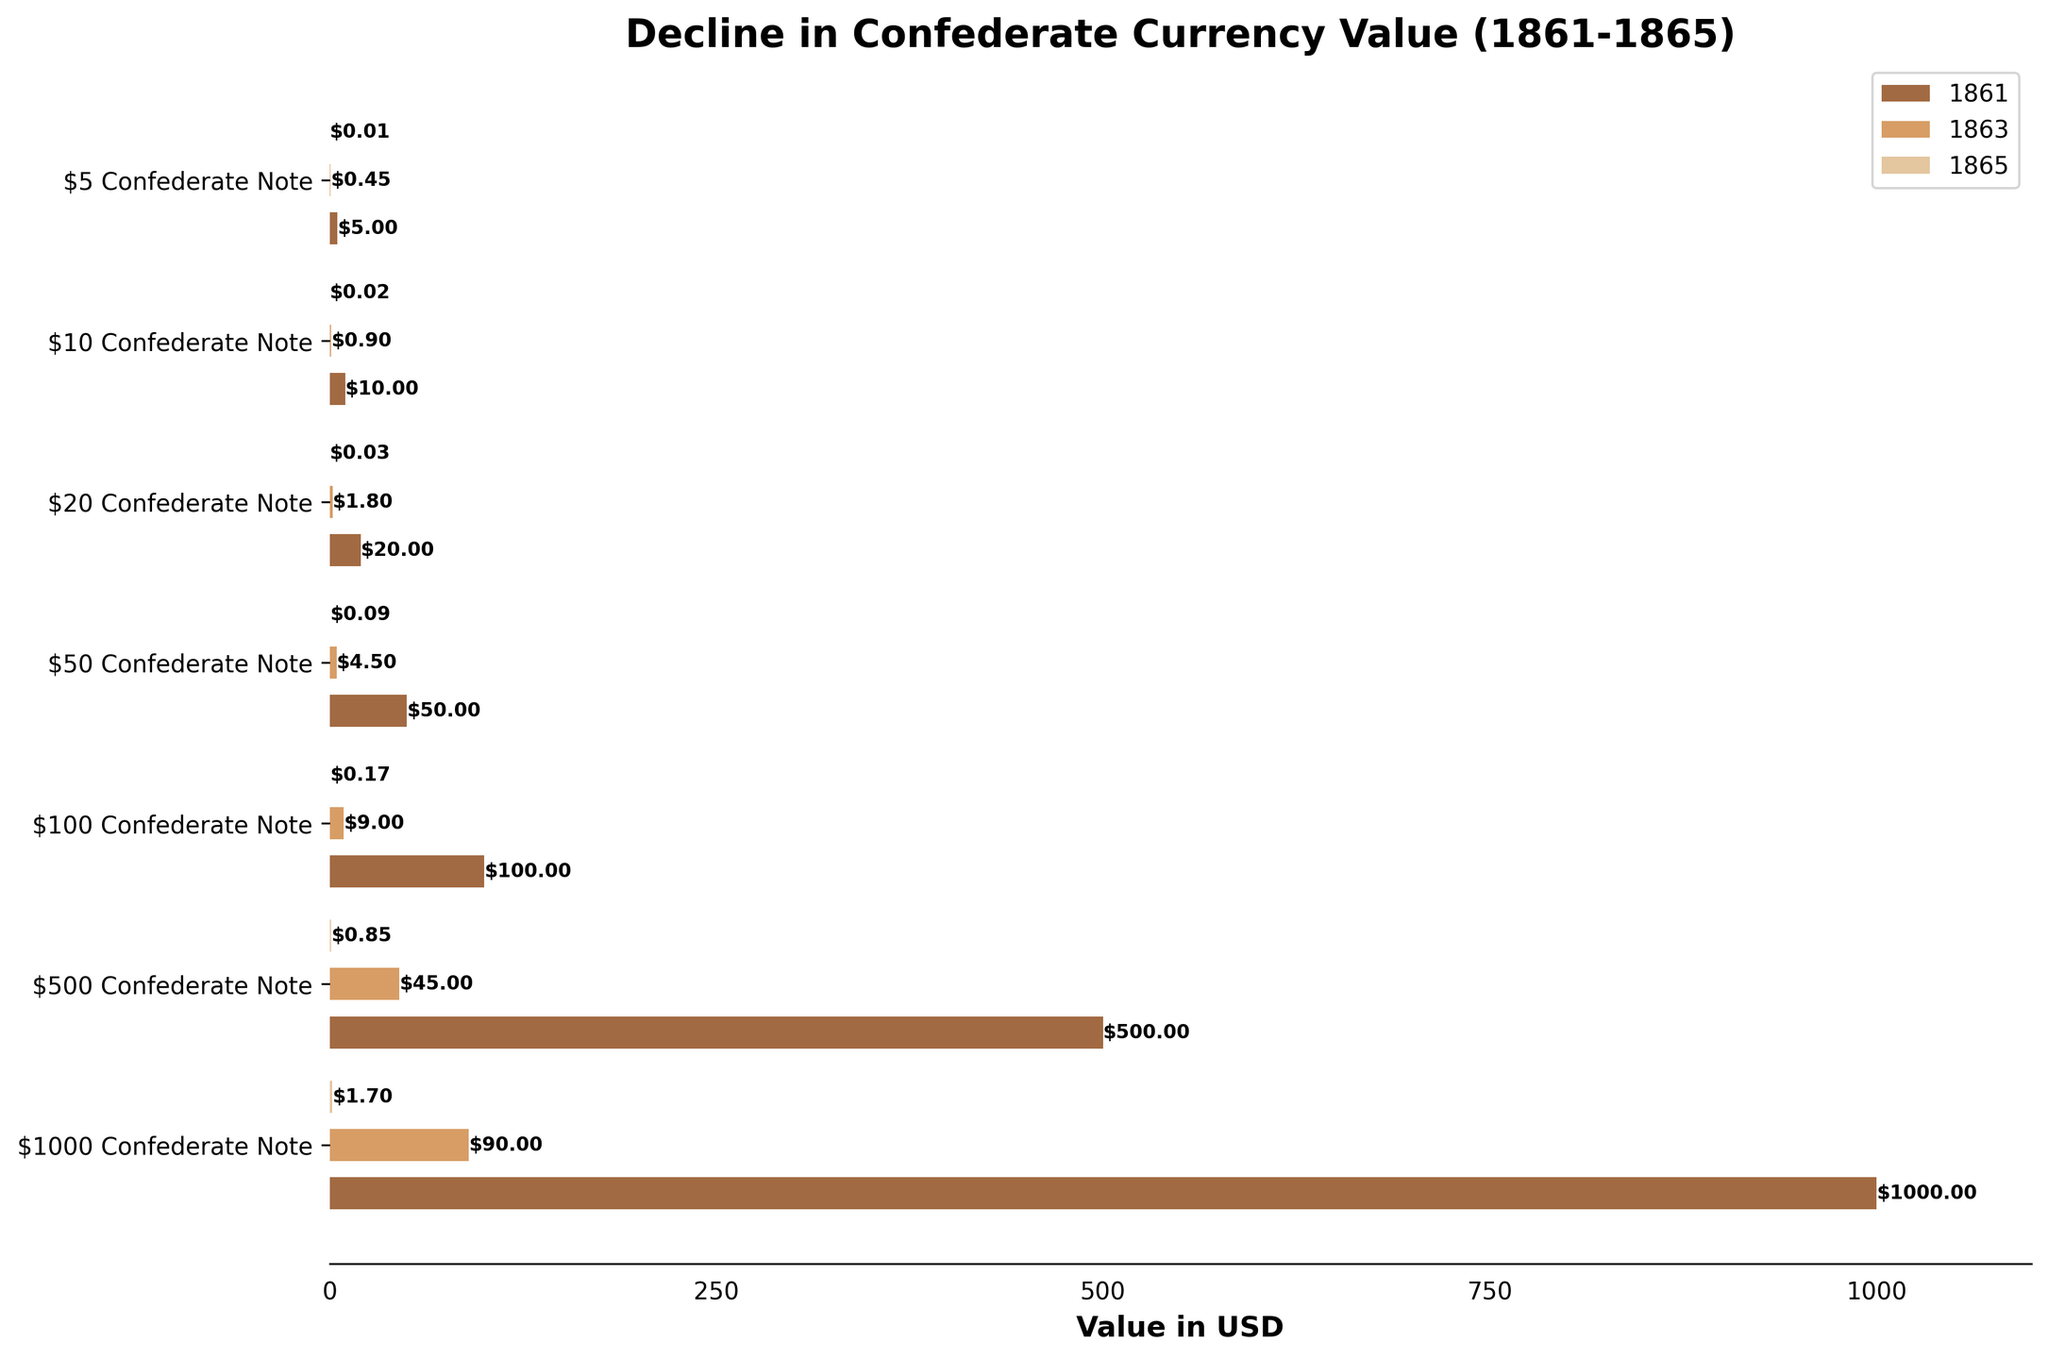what is the title of the chart? The title is displayed at the top of the chart. It provides an overview of what the chart is about.
Answer: Decline in Confederate Currency Value (1861-1865) Which year had the highest value for the $500 Confederate Note? By observing the bars in the chart, we can see the largest value for the $500 Confederate Note is in the year 1861.
Answer: 1861 How much did the value of the $50 Confederate Note decline from 1861 to 1865? The value in 1861 was $50, and it declined to $0.085 in 1865. The decline can be calculated as 50 - 0.085.
Answer: 49.915 Between 1863 and 1865, which denomination experienced the greatest percentage decrease in value? We calculate the percentage decrease for each denomination from 1863 to 1865 and compare them. The formula for percentage decrease is ((1863 Value - 1865 Value) / 1863 Value) * 100. The percentage decreases: 
$1000 Note: ((90 - 1.7) / 90) * 100 = 98.11%
$500 Note: ((45 - 0.85) / 45) * 100 = 98.11%
$100 Note: ((9 - 0.17) / 9) * 100 = 98.11%
$50 Note: ((4.5 - 0.085) / 4.5) * 100 = 98.11%
$20 Note: ((1.8 - 0.034) / 1.8) * 100 = 98.11%
$10 Note: ((0.9 - 0.017) / 0.9) * 100 = 98.11%
$5 Note: ((0.45 - 0.0085) / 0.45) * 100 = 98.11%. All denominations experienced the same percentage decrease.
Answer: All denominations had the same percentage decrease Looking at the $100 Confederate Note, what was its value as a percentage of its original value in 1861 by 1865? The value in 1865 was $0.17, and the original value in 1861 was $100. The percentage of its original value can be calculated by (0.17 / 100) * 100.
Answer: 0.17% Which denomination had the smallest absolute monetary decline from 1861 to 1865? The absolute monetary decline is calculated as the difference between the 1861 value and the 1865 value. Calculating for each:
$1000 Note: 1000 - 1.7 = 998.3
$500 Note: 500 - 0.85 = 499.15
$100 Note: 100 - 0.17 = 99.83
$50 Note: 50 - 0.085 = 49.915
$20 Note: 20 - 0.034 = 19.966
$10 Note: 10 - 0.017 = 9.983
$5 Note: 5 - 0.0085 = 4 .9915. The smallest absolute decline is $5 Confederate Note.
Answer: $5 Confederate Note Which year saw the largest drop in value for the $1000 Confederate Note? By comparing the bars for the $1000 Confederate Note, the value drops from $1000 in 1861 to $90 in 1863 (910 drop), and from $90 in 1863 to $1.7 in 1865 (88.3 drop). The largest drop happened between 1861 and 1863.
Answer: Between 1861 and 1863 How many denominations are displayed in the chart? By counting the number of labels on the y-axis, we can determine the number of denominations.
Answer: 7 